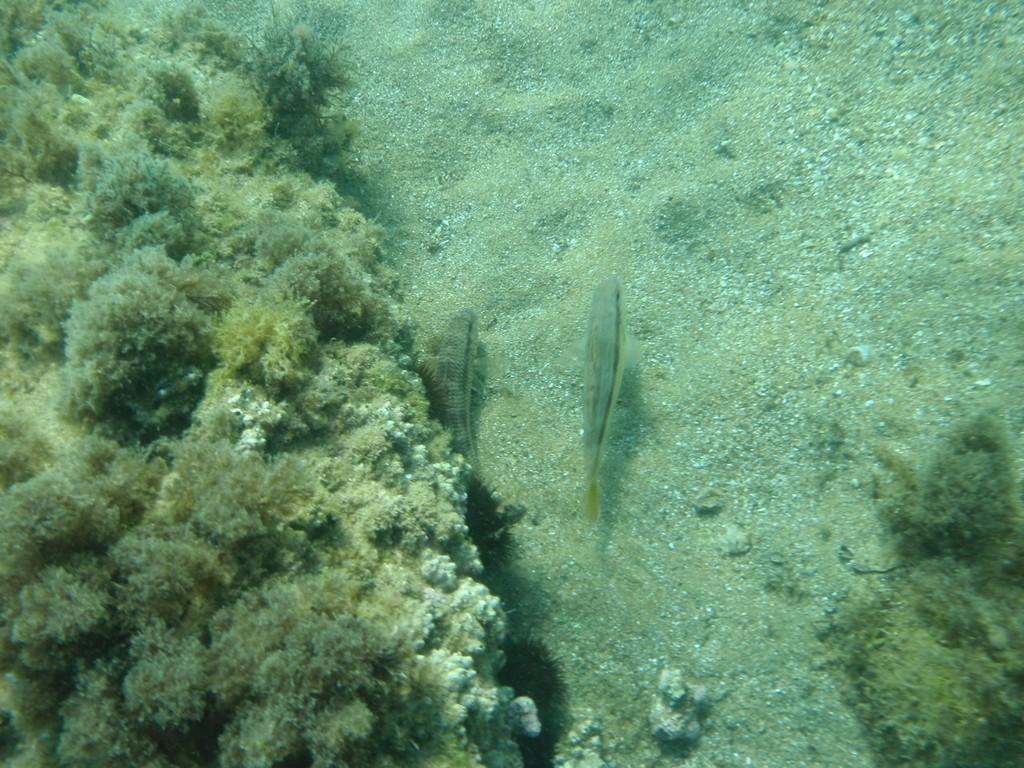Please provide a concise description of this image. In the image there are two fishes in the underwater and around those fishes there is a sand and some plants. 